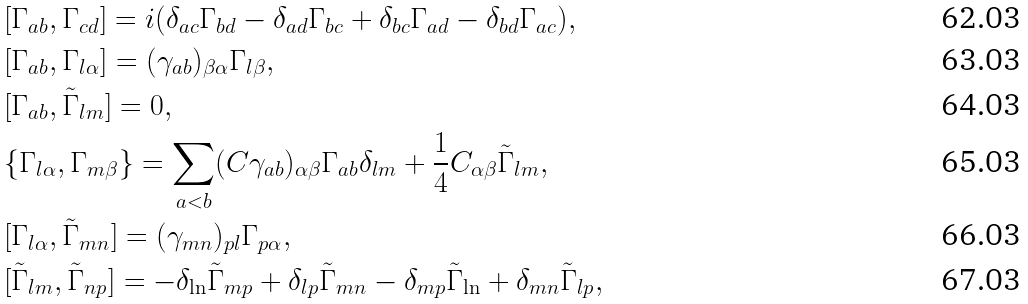Convert formula to latex. <formula><loc_0><loc_0><loc_500><loc_500>& [ \Gamma _ { a b } , \Gamma _ { c d } ] = i ( \delta _ { a c } { \Gamma } _ { b d } - \delta _ { a d } { \Gamma } _ { b c } + \delta _ { b c } { \Gamma } _ { a d } - \delta _ { b d } { \Gamma } _ { a c } ) , \\ & [ \Gamma _ { a b } , \Gamma _ { l \alpha } ] = ( \gamma _ { a b } ) _ { \beta \alpha } \Gamma _ { l \beta } , \\ & [ \Gamma _ { a b } , \tilde { \Gamma } _ { l m } ] = 0 , \\ & \{ \Gamma _ { l \alpha } , \Gamma _ { m \beta } \} = \sum _ { a < b } ( C \gamma _ { a b } ) _ { \alpha \beta } \Gamma _ { a b } \delta _ { l m } + \frac { 1 } { 4 } C _ { \alpha \beta } \tilde { \Gamma } _ { l m } , \\ & [ \Gamma _ { l \alpha } , \tilde { \Gamma } _ { m n } ] = ( \gamma _ { m n } ) _ { p l } \Gamma _ { p \alpha } , \\ & [ \tilde { \Gamma } _ { l m } , \tilde { \Gamma } _ { n p } ] = - \delta _ { \ln } { \tilde { \Gamma } } _ { m p } + \delta _ { l p } \tilde { \Gamma } _ { m n } - \delta _ { m p } \tilde { \Gamma } _ { \ln } + \delta _ { m n } \tilde { \Gamma } _ { l p } ,</formula> 